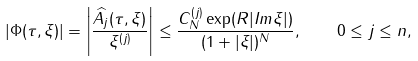Convert formula to latex. <formula><loc_0><loc_0><loc_500><loc_500>\left | \Phi ( \tau , \xi ) \right | = \left | \frac { \widehat { A _ { j } } ( \tau , \xi ) } { \xi ^ { ( j ) } } \right | \leq \frac { C _ { N } ^ { ( j ) } \exp ( R | I m \xi | ) } { ( 1 + | \xi | ) ^ { N } } , \quad 0 \leq j \leq n ,</formula> 